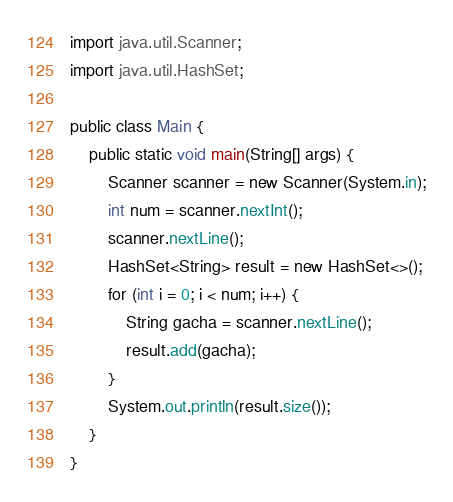<code> <loc_0><loc_0><loc_500><loc_500><_Java_>import java.util.Scanner;
import java.util.HashSet;

public class Main {
    public static void main(String[] args) {
        Scanner scanner = new Scanner(System.in);
        int num = scanner.nextInt();
        scanner.nextLine();
        HashSet<String> result = new HashSet<>();
        for (int i = 0; i < num; i++) {
            String gacha = scanner.nextLine();
            result.add(gacha);
        }
        System.out.println(result.size());
    }
}</code> 